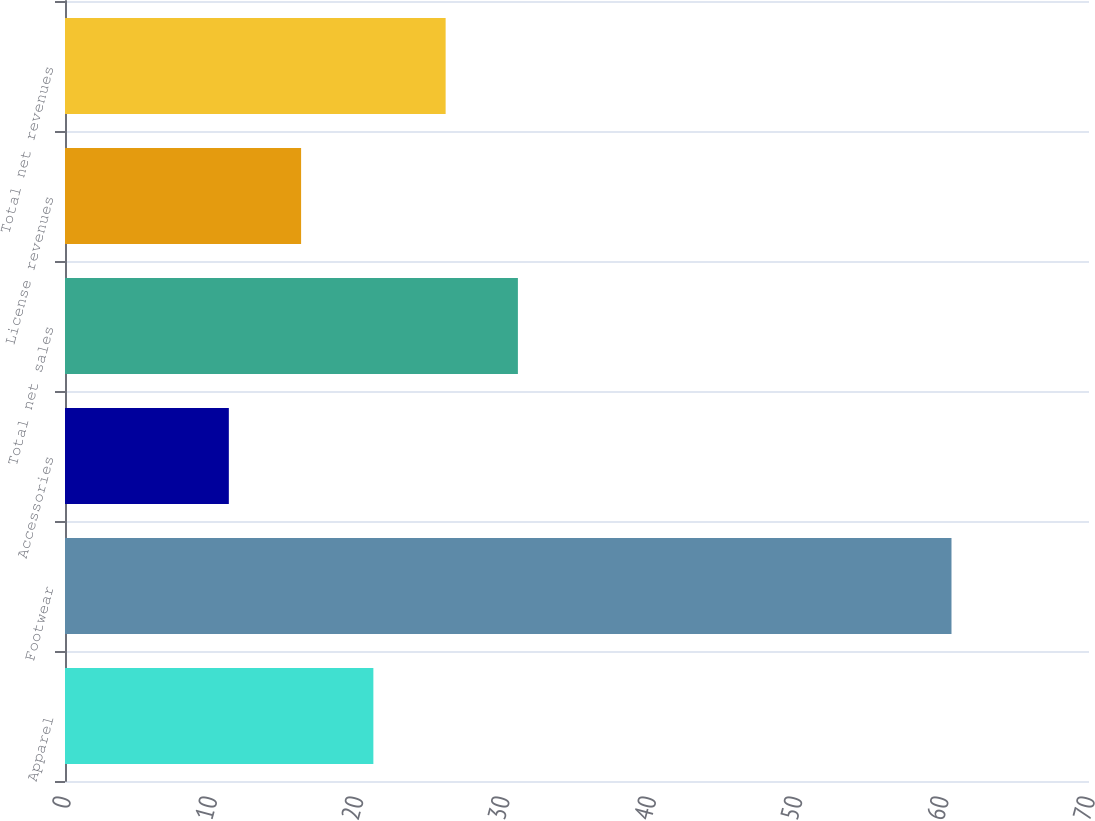Convert chart. <chart><loc_0><loc_0><loc_500><loc_500><bar_chart><fcel>Apparel<fcel>Footwear<fcel>Accessories<fcel>Total net sales<fcel>License revenues<fcel>Total net revenues<nl><fcel>21.08<fcel>60.6<fcel>11.2<fcel>30.96<fcel>16.14<fcel>26.02<nl></chart> 